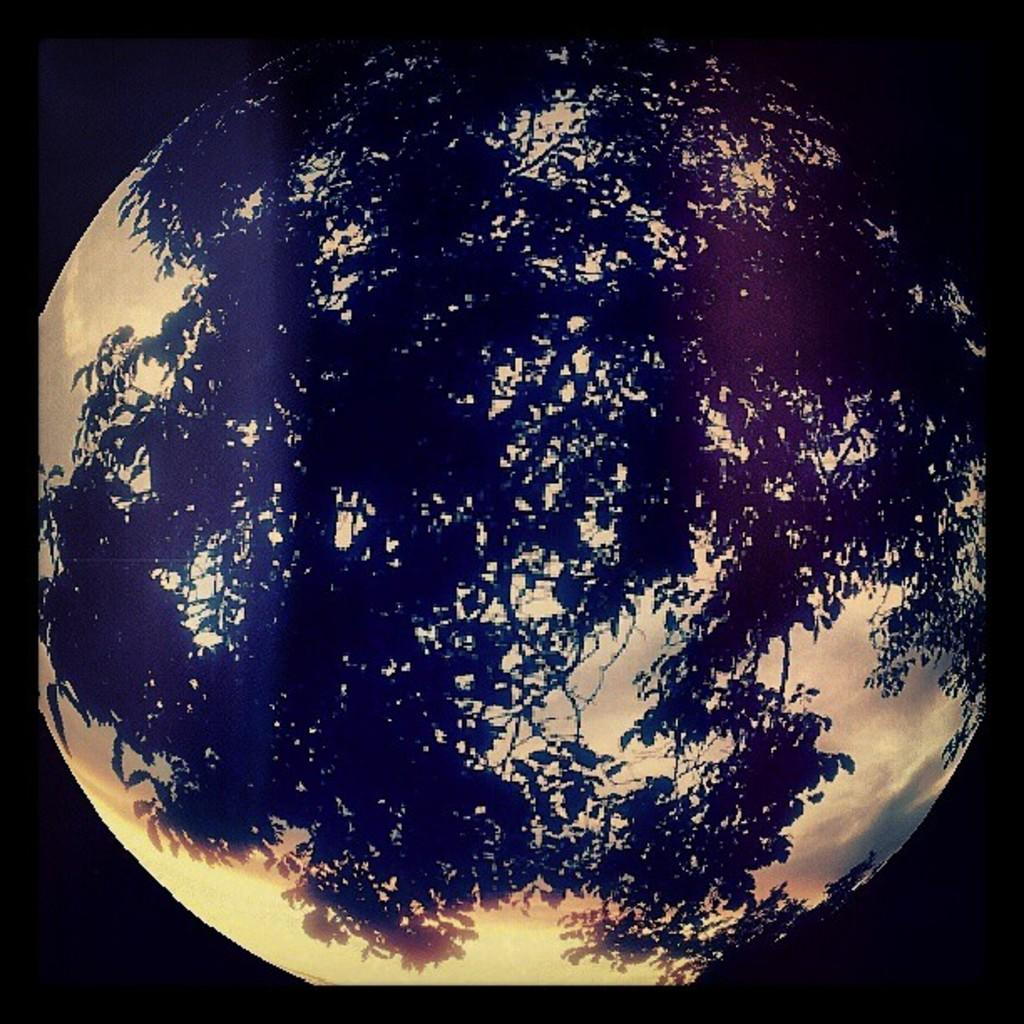What is the main subject of the image? The main subject of the image is a tree reflection. Can you describe the reflection in more detail? The reflection shows the tree's image on a surface, likely water or a mirror-like surface. What type of committee can be seen discussing the tree's reflection in the image? There is no committee present in the image, and the tree's reflection is not being discussed by any group. 